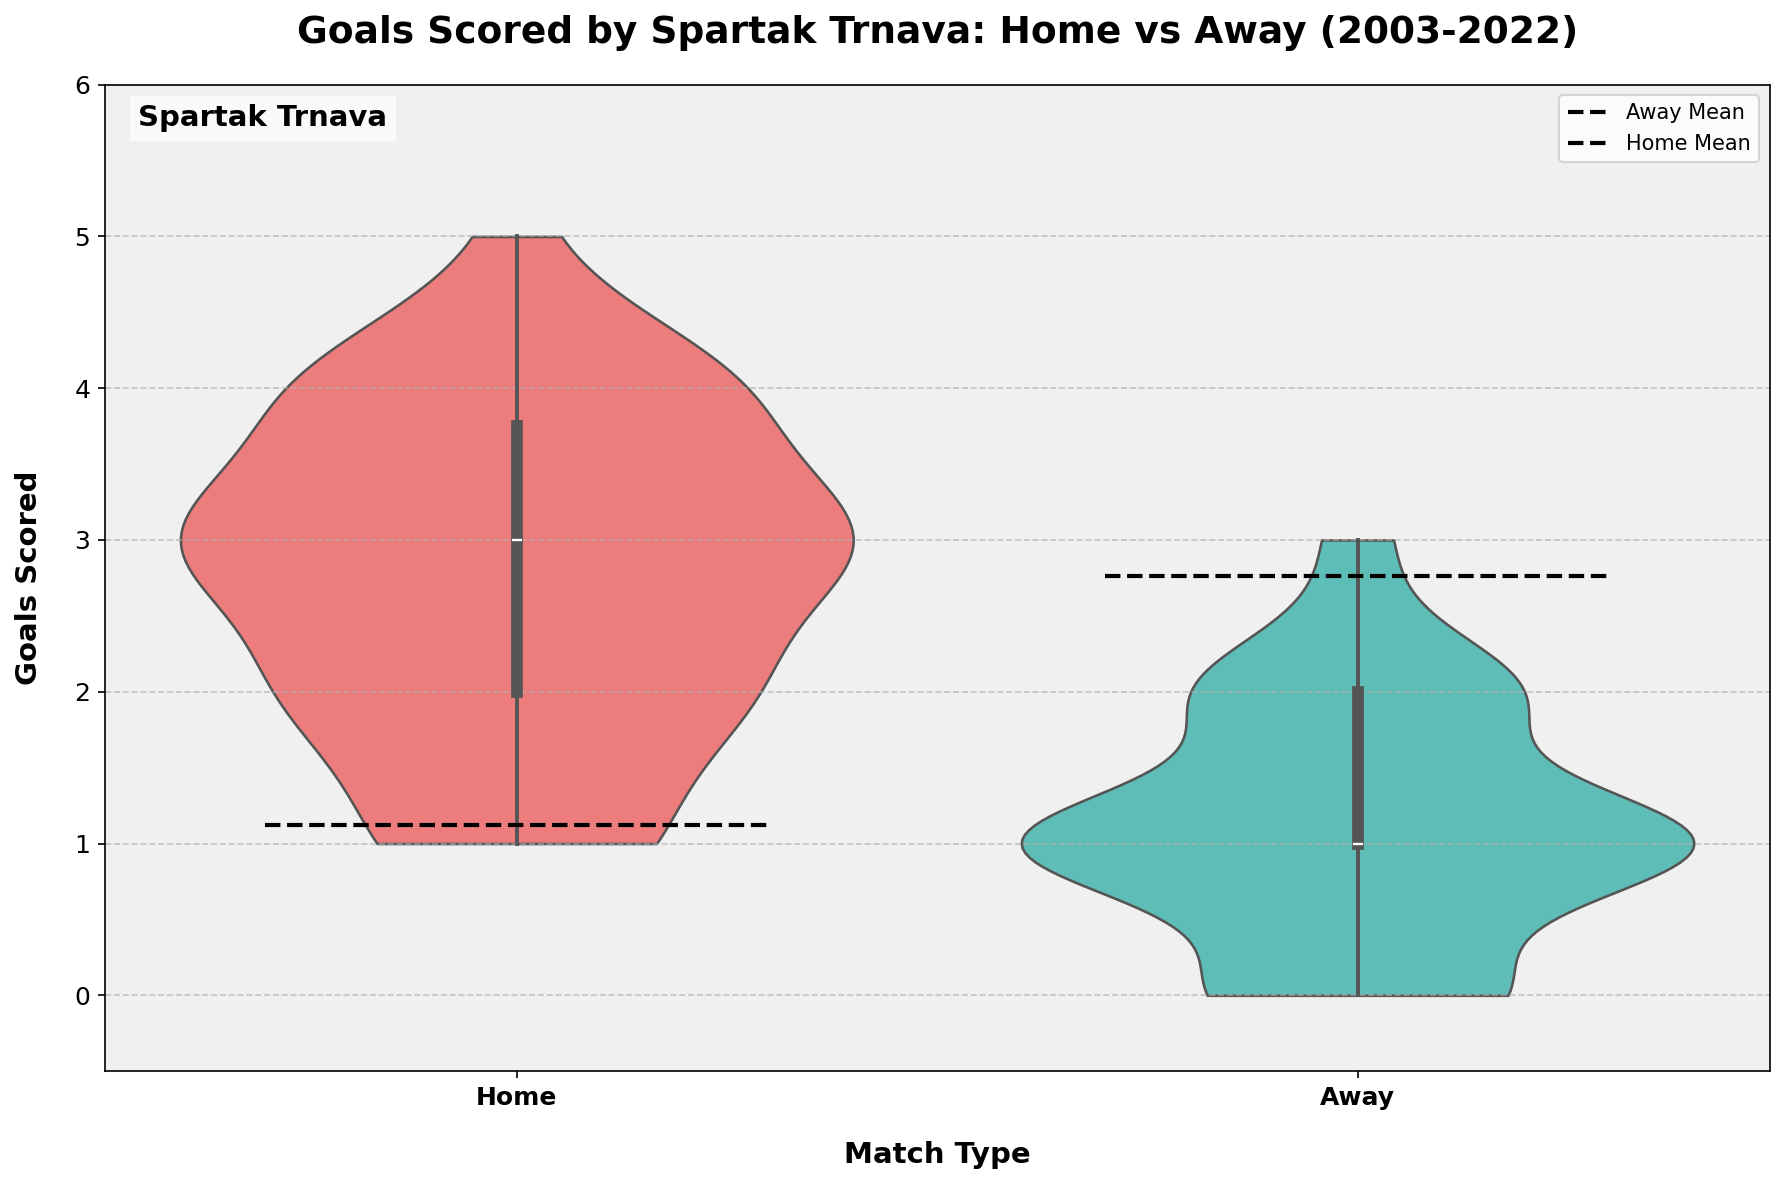What sport does the plot depict? The title of the plot states "Goals Scored by Spartak Trnava: Home vs Away (2003-2022)," indicating the sport is football.
Answer: Football What is the highest number of goals scored by Spartak Trnava in a single home match? The y-axis marks the number of goals scored, and from the figure, the highest point for home matches reaches 5 goals.
Answer: 5 What color is used to represent home matches in the plot? The legend and the violin plot colors indicate that home matches are represented by a red color.
Answer: Red Which match type has a higher mean goals scored, home or away? The plot includes dashed lines to indicate mean goals for each match type. The dashed line for home matches is higher than that for away matches.
Answer: Home What is the median number of goals scored in away matches? The box plot within the violin chart indicates the median as the line inside the box. For away matches, this line is at 1 goal.
Answer: 1 Which match type exhibits a greater spread in the number of goals scored? The width of the violin plots reflects the distribution's spread. The home match plot is wider and extends higher, indicating a greater spread in the number of goals scored.
Answer: Home By how many goals does the mean number of goals scored in home matches exceed the mean number of goals scored in away matches? The mean for home matches is around 3 goals, and the mean for away matches is around 1.5 goals. The difference is 3 - 1.5 = 1.5.
Answer: 1.5 Is the distribution of goals more symmetrical for home or away matches? The shape of the violin plots reflects symmetry. The away match distribution appears more symmetrical compared to the home match distribution.
Answer: Away What patterns can be observed regarding the lower box plot whisker in away matches? The lower whisker in the box plot for away matches extends to 0, indicating that 25% of away matches had 0 goals scored.
Answer: 0 How often did Spartak Trnava score at least 4 goals in home matches compared to away matches? Looking at the violin plot's upper end, Spartak Trnava scored at least 4 goals in home matches more often, while for away matches, it almost never went beyond 3 goals.
Answer: More often in home matches 